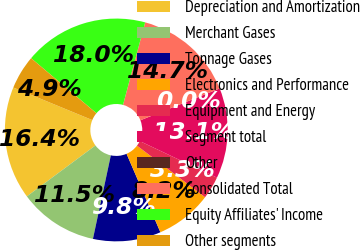Convert chart. <chart><loc_0><loc_0><loc_500><loc_500><pie_chart><fcel>Depreciation and Amortization<fcel>Merchant Gases<fcel>Tonnage Gases<fcel>Electronics and Performance<fcel>Equipment and Energy<fcel>Segment total<fcel>Other<fcel>Consolidated Total<fcel>Equity Affiliates' Income<fcel>Other segments<nl><fcel>16.39%<fcel>11.47%<fcel>9.84%<fcel>8.2%<fcel>3.28%<fcel>13.11%<fcel>0.01%<fcel>14.75%<fcel>18.03%<fcel>4.92%<nl></chart> 